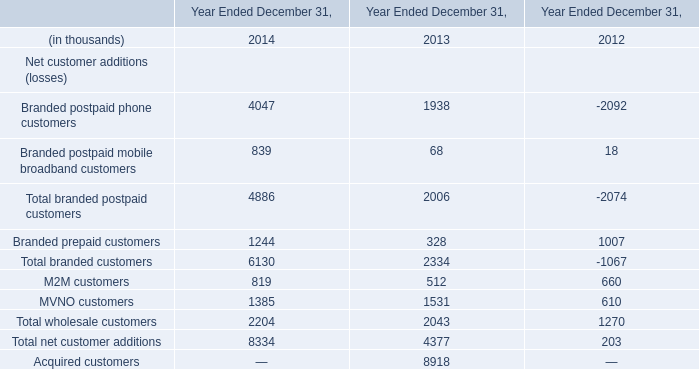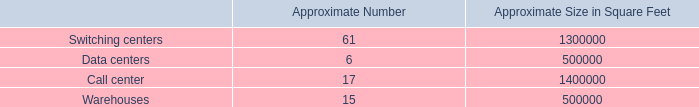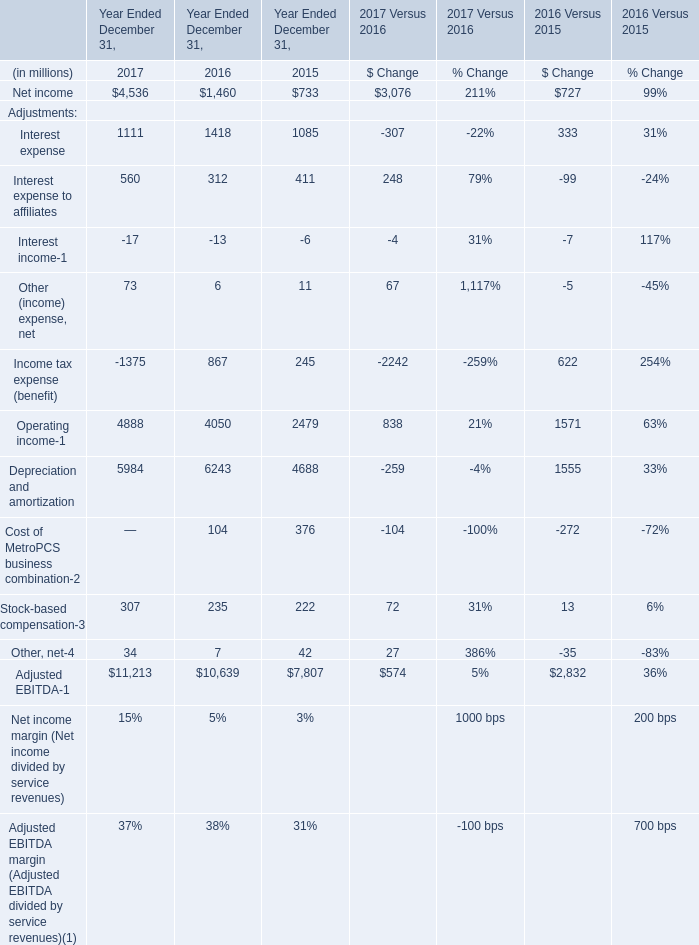what is the ratio of the office space throughout the us to the office space for the corporate headquarters in bellevue 
Computations: (1700000 / 900000)
Answer: 1.88889. 